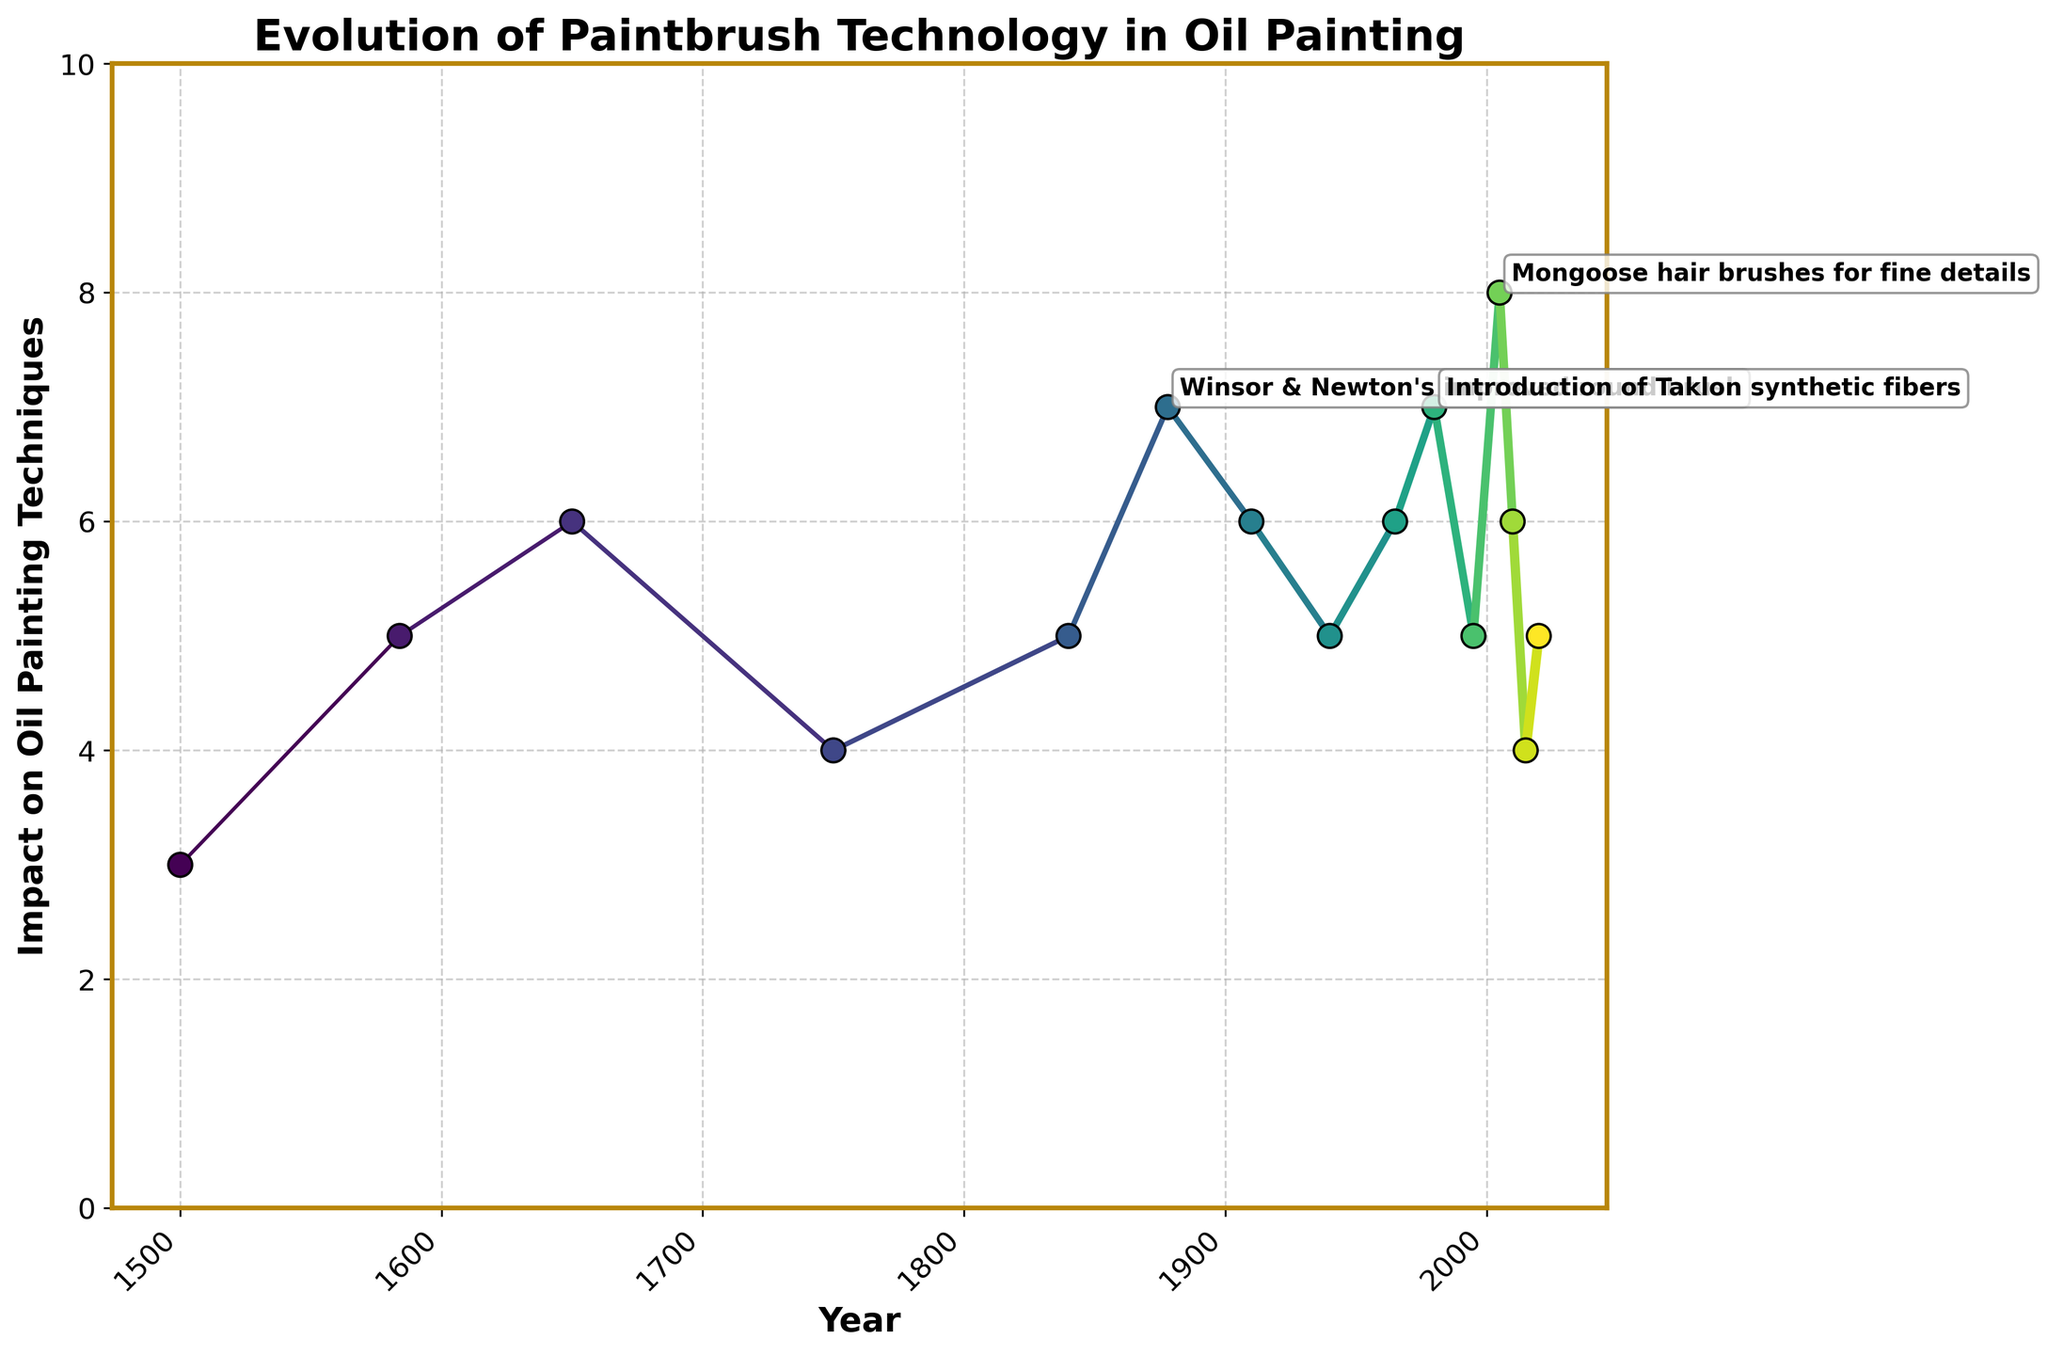Which year shows the highest impact on oil painting techniques? Look for the year with the highest point in the vertical direction. The highest impact score is 8 for the year 2005.
Answer: 2005 Which development had an impact score of 7 and occurred after 1970? Identify the points with an impact score of 7 and then check the corresponding years after 1970. The points with an impact of 7 after 1970 are in 1980 for "Introduction of Taklon synthetic fibers".
Answer: 1980 How many developments had an impact score of 6? Count the number of data points where the impact score is 6. These occur in 1650, 1910, 1965, and 2010.
Answer: 4 Which development in the 17th century (1600-1700) had an impact score closest to 5? Evaluate the impact scores within the range from 1600 to 1700. The impact score closest to 5 is for "Emergence of red sable brushes" with a score of 6 in 1650.
Answer: 1650 Are there any developments that had the same impact score of 5 but occurred in different centuries? If so, which ones? Look for data points with an impact score of 5 across different centuries. These are "Invention of the flat brush by Rubens" in 1584, "Development of the fan brush" in 1840, "Introduction of nylon bristles" in 1940, "Ergonomic brush handles" in 1995, and "Introduction of eco-friendly bamboo handle brushes" in 2020.
Answer: Yes, Rubens' flat brush (1584), fan brush (1840), nylon bristles (1940), ergonomic handles (1995), and bamboo handles (2020) What is the trend in impact on oil painting techniques after the introduction of synthetic bristles in 1750? Starting from the year 1750, note the changes in impact scores over time. The impact increased from 4 in 1750 to 5 in 1840, 7 in 1878, 6 in 1910, and sees some fluctuation thereafter.
Answer: Increasing then fluctuating How many developments have been introduced since 2000, and what are their impact scores? Examine the data points from the year 2000 onward. The developments are "Mongoose hair brushes for fine details" in 2005 with an impact of 8, "Synthetic squirrel hair brushes" in 2010 with an impact of 6, "Development of self-cleaning brushes" in 2015 with an impact of 4, and "Introduction of eco-friendly bamboo handle brushes" in 2020 with an impact of 5.
Answer: 4 (Impact: 8, 6, 4, 5) Compare the impact on oil painting techniques between the developments in 1910 and 1940. Which one had a higher impact? Check the impact scores for 1910 and 1940. The scores are 6 for 1910 ("Invention of the filbert brush") and 5 for 1940 ("Introduction of nylon bristles").
Answer: 1910 Among the developments annotated on the chart with an impact score of 7 or above, which one occurred the earliest? Identify the annotated points with an impact score of 7 or above, then find the earliest year among them. The points are in 1878, 1980, and 2005. The earliest year is 1878 for "Winsor & Newton's improved round brush".
Answer: 1878 What is the average impact score of developments introduced in the 20th century? Calculate the average impact score for the years 1900-1999, which includes 1910 (impact: 6), 1940 (impact: 5), 1965 (impact: 6), and 1980 (impact: 7). The average is (6 + 5 + 6 + 7) / 4 = 6.
Answer: 6 